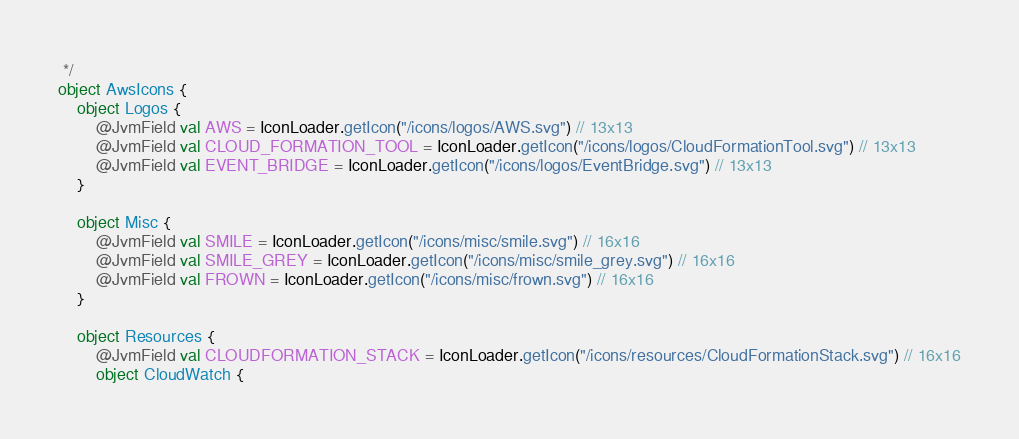<code> <loc_0><loc_0><loc_500><loc_500><_Kotlin_> */
object AwsIcons {
    object Logos {
        @JvmField val AWS = IconLoader.getIcon("/icons/logos/AWS.svg") // 13x13
        @JvmField val CLOUD_FORMATION_TOOL = IconLoader.getIcon("/icons/logos/CloudFormationTool.svg") // 13x13
        @JvmField val EVENT_BRIDGE = IconLoader.getIcon("/icons/logos/EventBridge.svg") // 13x13
    }

    object Misc {
        @JvmField val SMILE = IconLoader.getIcon("/icons/misc/smile.svg") // 16x16
        @JvmField val SMILE_GREY = IconLoader.getIcon("/icons/misc/smile_grey.svg") // 16x16
        @JvmField val FROWN = IconLoader.getIcon("/icons/misc/frown.svg") // 16x16
    }

    object Resources {
        @JvmField val CLOUDFORMATION_STACK = IconLoader.getIcon("/icons/resources/CloudFormationStack.svg") // 16x16
        object CloudWatch {</code> 